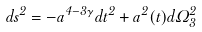<formula> <loc_0><loc_0><loc_500><loc_500>d s ^ { 2 } = - a ^ { 4 - 3 \gamma } d t ^ { 2 } + a ^ { 2 } ( t ) d \Omega ^ { 2 } _ { 3 }</formula> 